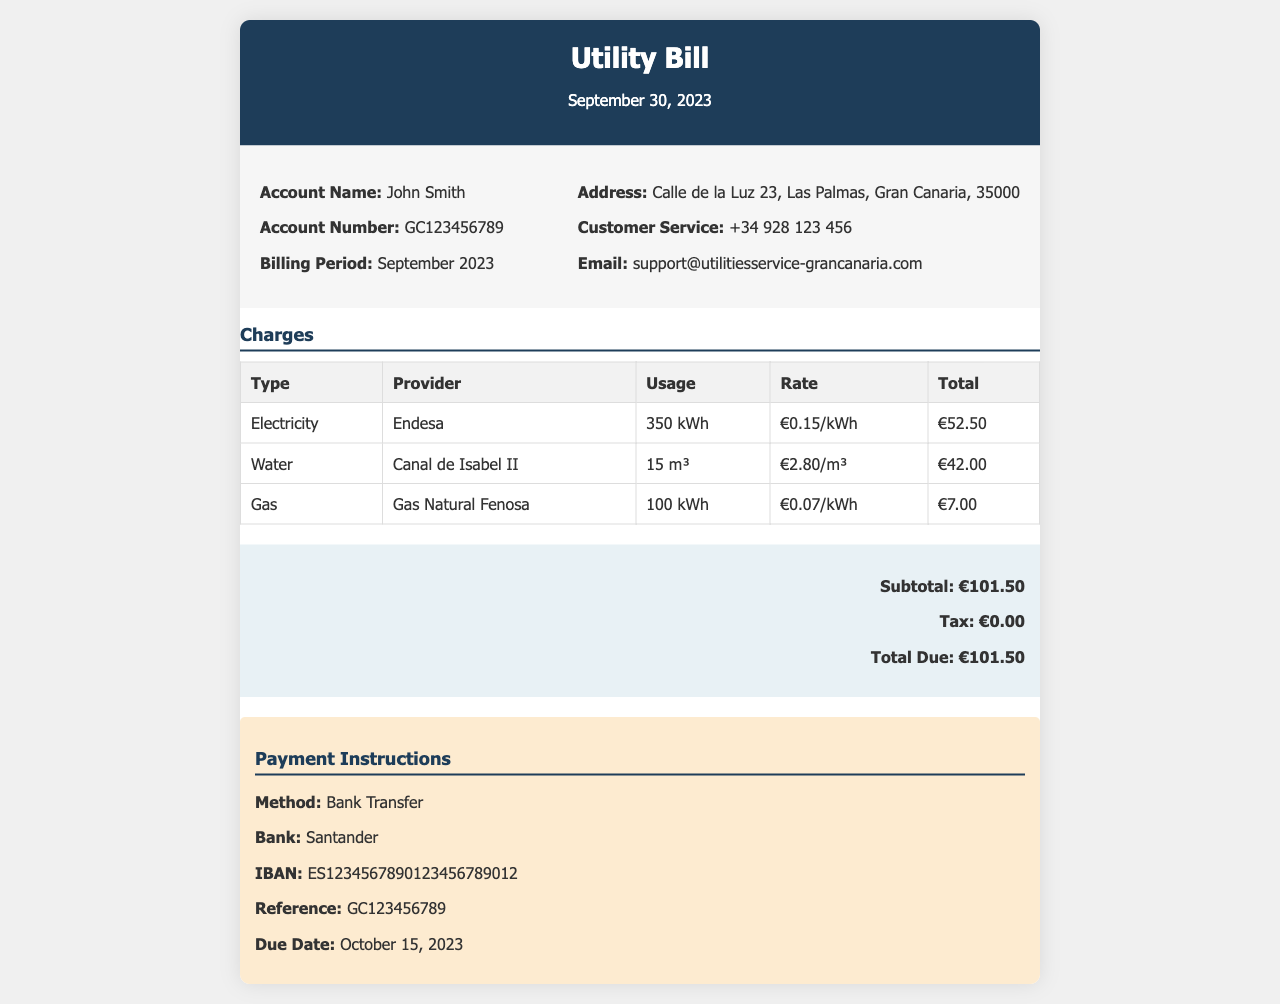What is the account name? The account name can be found in the invoice details section, and it is listed as "John Smith."
Answer: John Smith What is the total amount due? The total amount due is found in the total section of the invoice, which states "Total Due: €101.50."
Answer: €101.50 Which provider supplies the electricity? The provider listed for electricity in the charges table is "Endesa."
Answer: Endesa What was the water usage in the billing period? The water usage is specified in the charges table under the water section, indicating "15 m³."
Answer: 15 m³ What payment method is specified in the invoice? The payment method is indicated in the payment instructions section, which states "Bank Transfer."
Answer: Bank Transfer How many kWh of gas were used? The gas usage is detailed in the charges table, showing "100 kWh."
Answer: 100 kWh What is the rate per cubic meter for water? The rate for water is found in the charges table and is written as "€2.80/m³."
Answer: €2.80/m³ What is the due date for the payment? The due date can be found in the payment instructions section, where it states "Due Date: October 15, 2023."
Answer: October 15, 2023 What is the IBAN for the bank transfer? The IBAN is listed in the payment instructions section of the invoice as "ES1234567890123456789012."
Answer: ES1234567890123456789012 